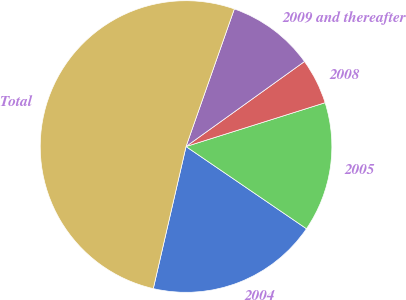<chart> <loc_0><loc_0><loc_500><loc_500><pie_chart><fcel>2004<fcel>2005<fcel>2008<fcel>2009 and thereafter<fcel>Total<nl><fcel>19.07%<fcel>14.39%<fcel>5.05%<fcel>9.72%<fcel>51.76%<nl></chart> 